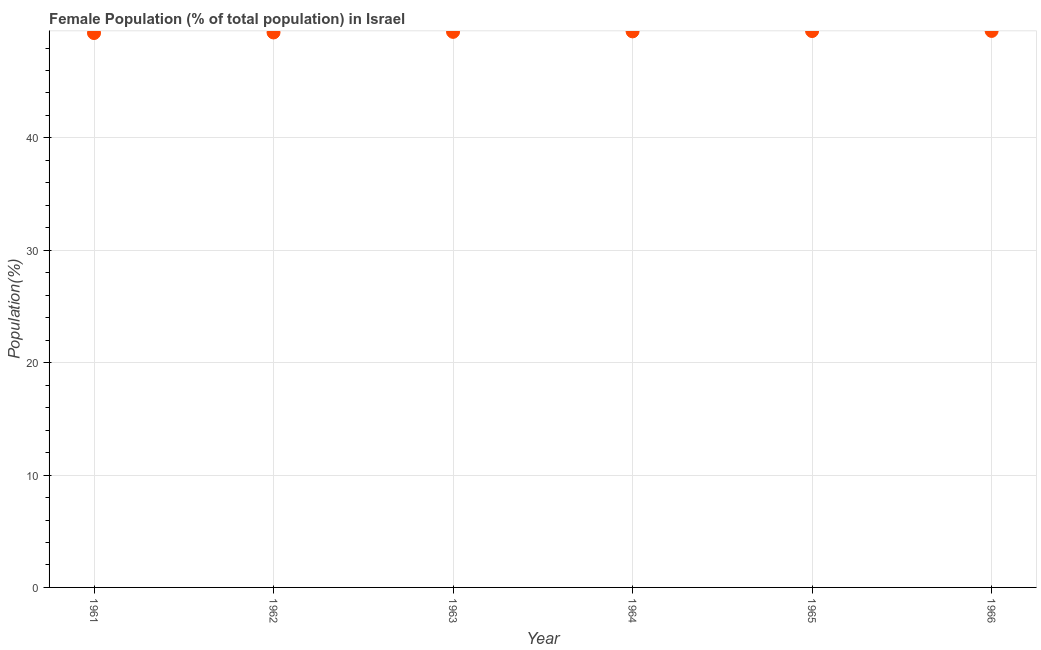What is the female population in 1962?
Give a very brief answer. 49.39. Across all years, what is the maximum female population?
Provide a short and direct response. 49.52. Across all years, what is the minimum female population?
Keep it short and to the point. 49.34. In which year was the female population maximum?
Your answer should be very brief. 1966. What is the sum of the female population?
Give a very brief answer. 296.68. What is the difference between the female population in 1962 and 1966?
Offer a terse response. -0.14. What is the average female population per year?
Keep it short and to the point. 49.45. What is the median female population?
Give a very brief answer. 49.46. Do a majority of the years between 1962 and 1963 (inclusive) have female population greater than 34 %?
Keep it short and to the point. Yes. What is the ratio of the female population in 1961 to that in 1966?
Your response must be concise. 1. What is the difference between the highest and the second highest female population?
Your answer should be very brief. 0.01. Is the sum of the female population in 1963 and 1964 greater than the maximum female population across all years?
Provide a short and direct response. Yes. What is the difference between the highest and the lowest female population?
Offer a very short reply. 0.19. Are the values on the major ticks of Y-axis written in scientific E-notation?
Ensure brevity in your answer.  No. Does the graph contain any zero values?
Offer a very short reply. No. What is the title of the graph?
Keep it short and to the point. Female Population (% of total population) in Israel. What is the label or title of the Y-axis?
Offer a very short reply. Population(%). What is the Population(%) in 1961?
Offer a very short reply. 49.34. What is the Population(%) in 1962?
Offer a very short reply. 49.39. What is the Population(%) in 1963?
Your answer should be compact. 49.44. What is the Population(%) in 1964?
Provide a succinct answer. 49.48. What is the Population(%) in 1965?
Provide a succinct answer. 49.51. What is the Population(%) in 1966?
Offer a very short reply. 49.52. What is the difference between the Population(%) in 1961 and 1962?
Give a very brief answer. -0.05. What is the difference between the Population(%) in 1961 and 1963?
Keep it short and to the point. -0.1. What is the difference between the Population(%) in 1961 and 1964?
Make the answer very short. -0.15. What is the difference between the Population(%) in 1961 and 1965?
Make the answer very short. -0.18. What is the difference between the Population(%) in 1961 and 1966?
Your answer should be compact. -0.19. What is the difference between the Population(%) in 1962 and 1963?
Make the answer very short. -0.05. What is the difference between the Population(%) in 1962 and 1964?
Offer a terse response. -0.1. What is the difference between the Population(%) in 1962 and 1965?
Make the answer very short. -0.12. What is the difference between the Population(%) in 1962 and 1966?
Your answer should be very brief. -0.14. What is the difference between the Population(%) in 1963 and 1964?
Ensure brevity in your answer.  -0.04. What is the difference between the Population(%) in 1963 and 1965?
Your answer should be very brief. -0.07. What is the difference between the Population(%) in 1963 and 1966?
Keep it short and to the point. -0.08. What is the difference between the Population(%) in 1964 and 1965?
Provide a short and direct response. -0.03. What is the difference between the Population(%) in 1964 and 1966?
Provide a succinct answer. -0.04. What is the difference between the Population(%) in 1965 and 1966?
Your answer should be compact. -0.01. What is the ratio of the Population(%) in 1961 to that in 1962?
Give a very brief answer. 1. What is the ratio of the Population(%) in 1961 to that in 1965?
Your answer should be very brief. 1. What is the ratio of the Population(%) in 1962 to that in 1964?
Your answer should be compact. 1. What is the ratio of the Population(%) in 1963 to that in 1964?
Provide a short and direct response. 1. What is the ratio of the Population(%) in 1963 to that in 1966?
Your answer should be very brief. 1. 